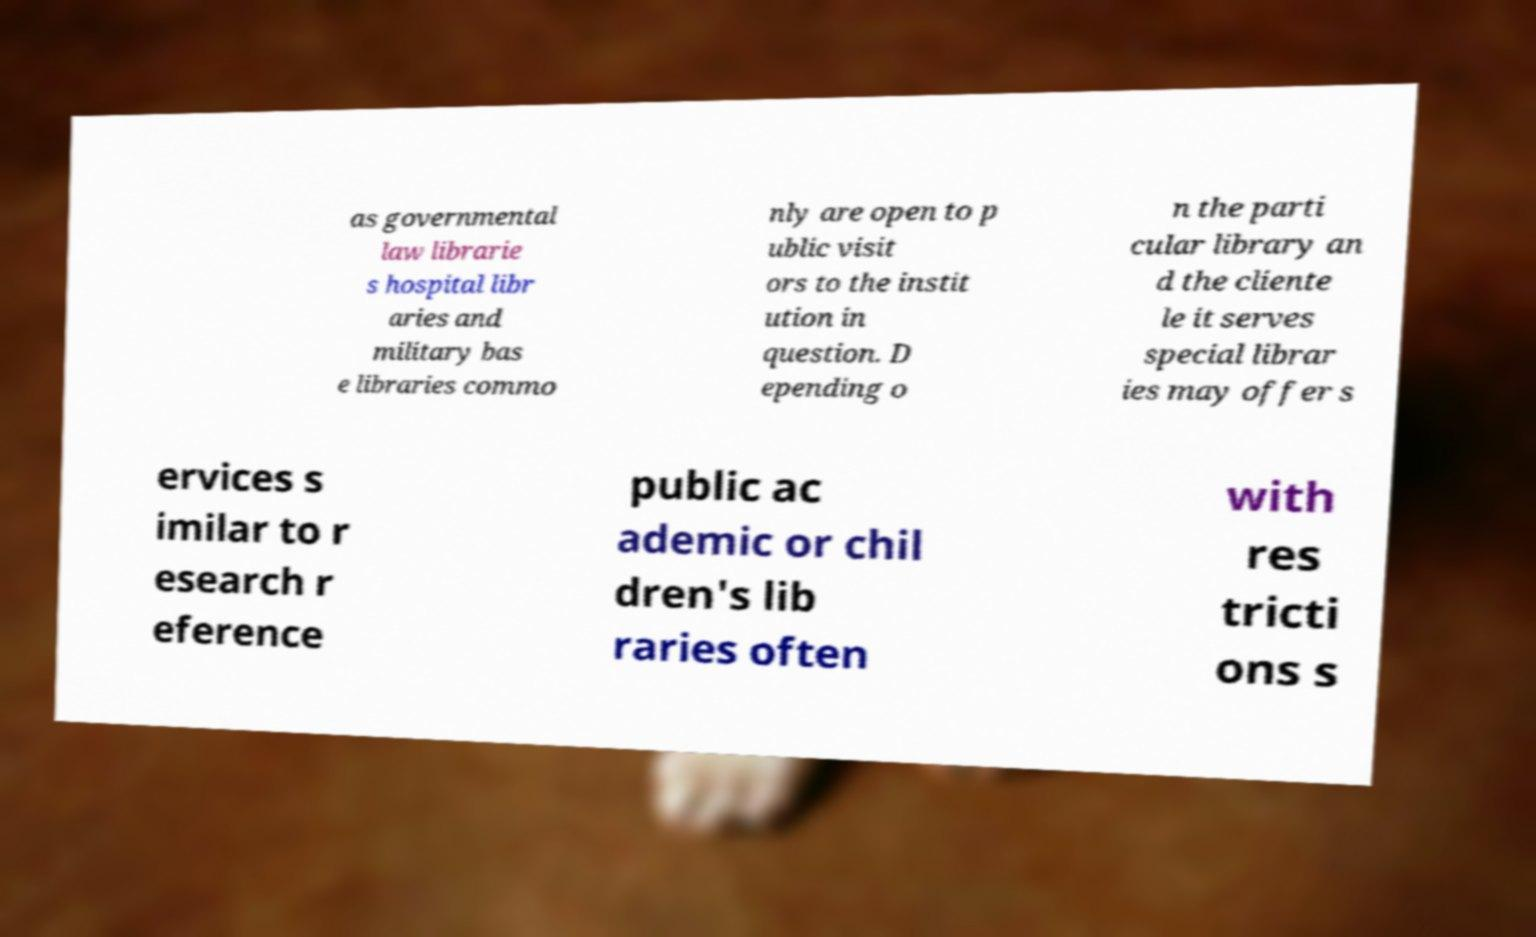Can you read and provide the text displayed in the image?This photo seems to have some interesting text. Can you extract and type it out for me? as governmental law librarie s hospital libr aries and military bas e libraries commo nly are open to p ublic visit ors to the instit ution in question. D epending o n the parti cular library an d the cliente le it serves special librar ies may offer s ervices s imilar to r esearch r eference public ac ademic or chil dren's lib raries often with res tricti ons s 